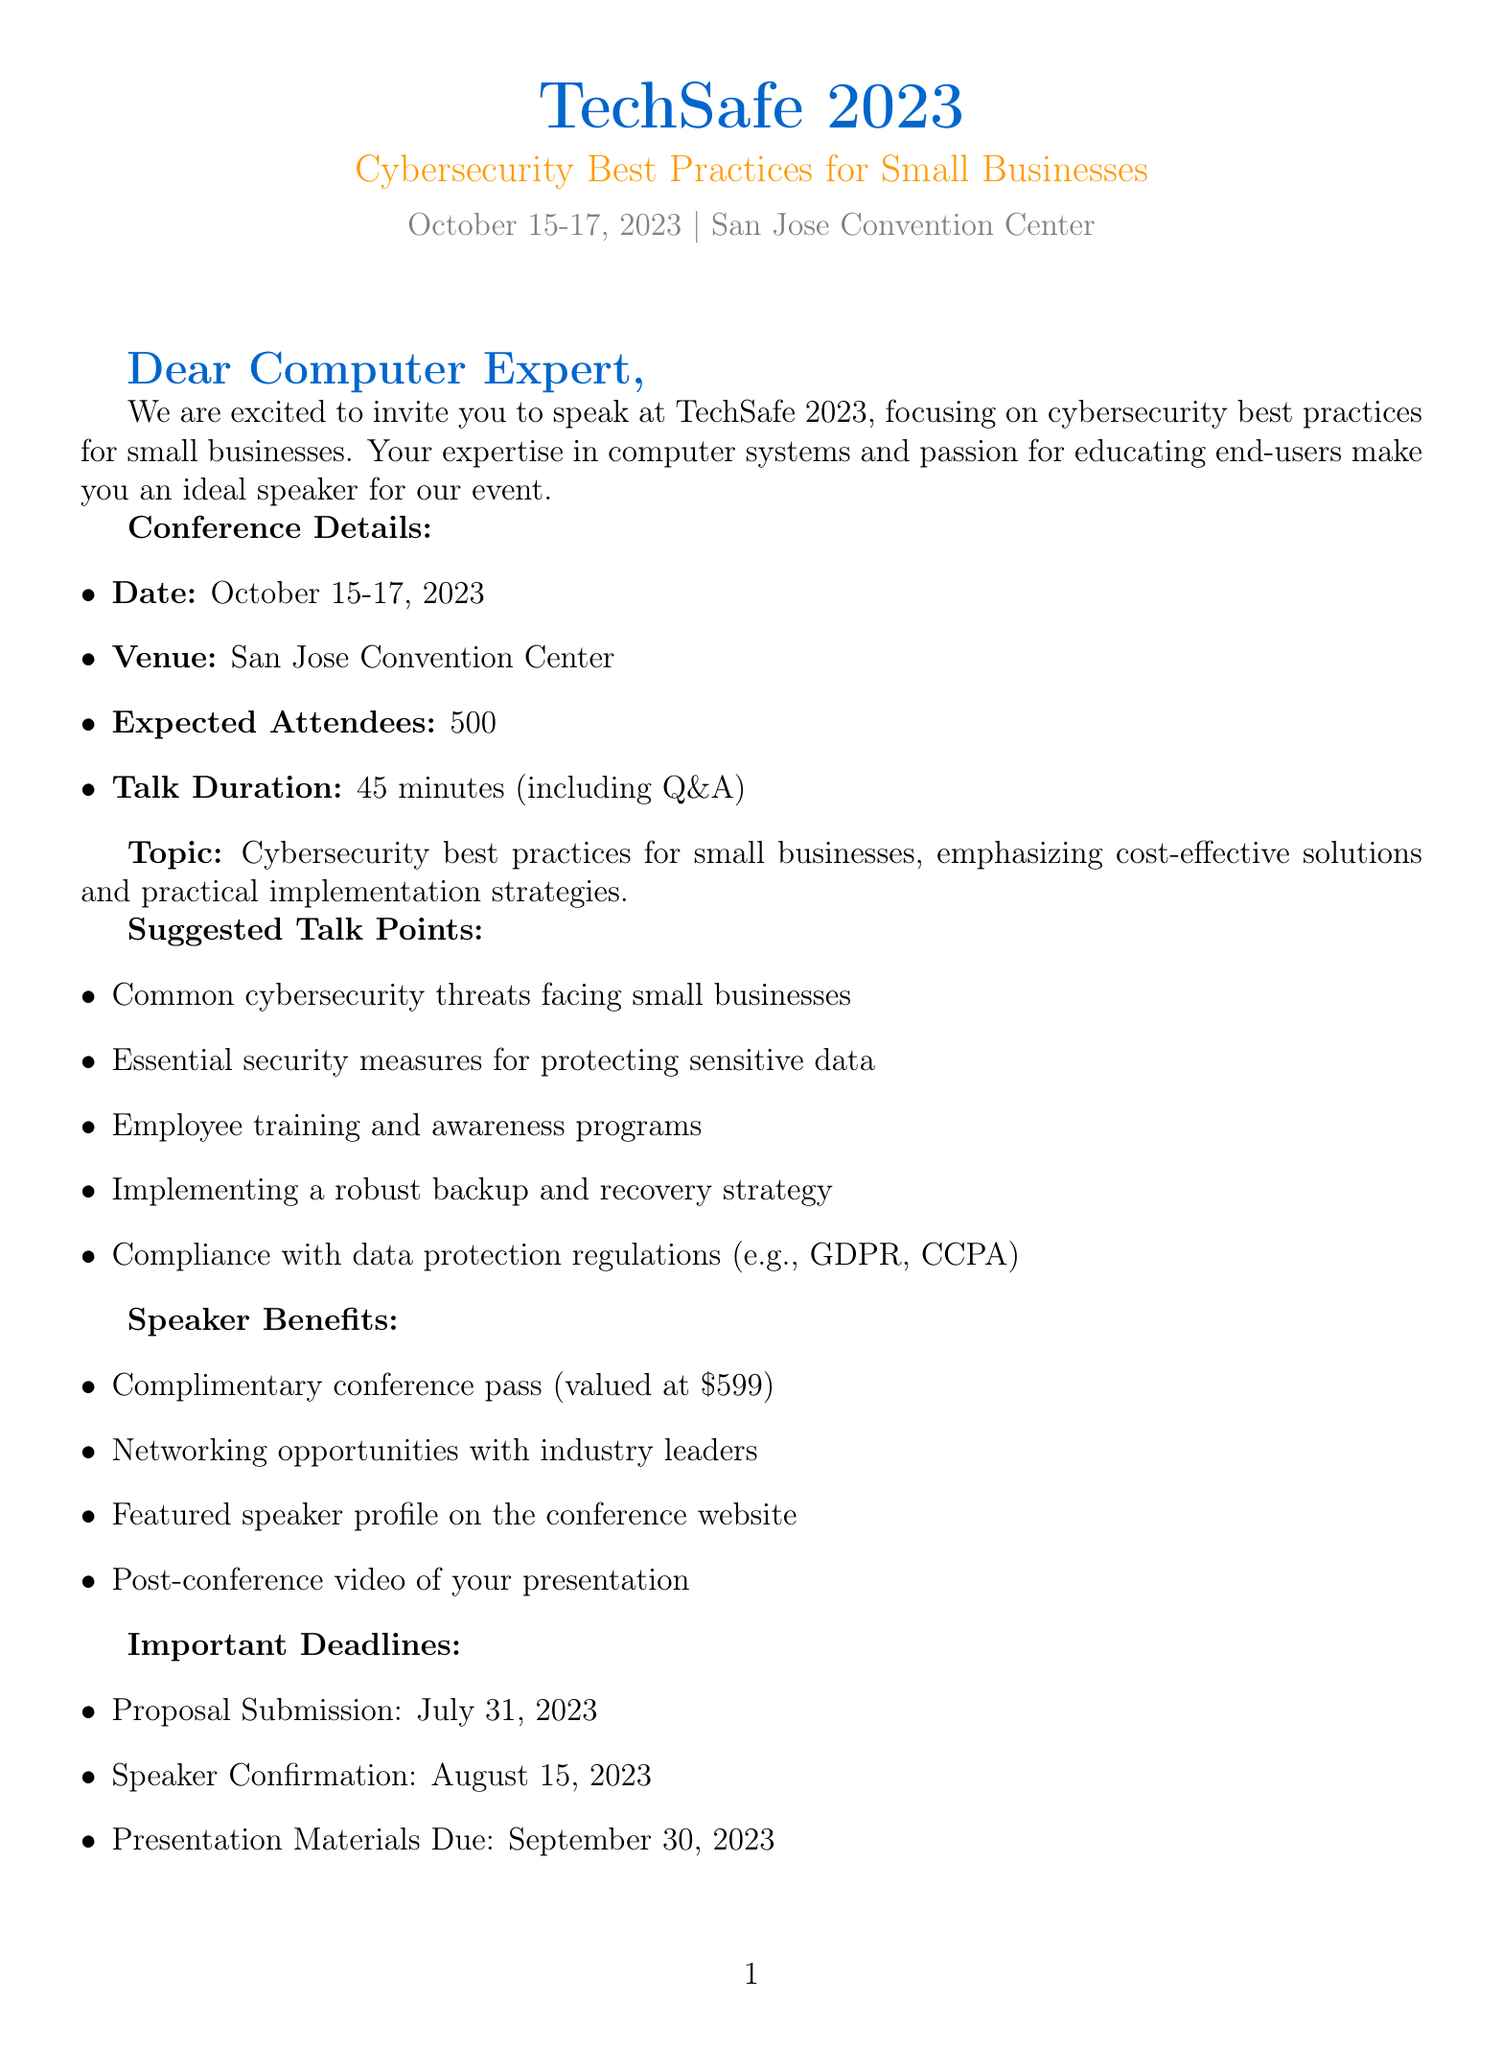What is the name of the conference? The name of the conference is mentioned in the document as TechSafe 2023.
Answer: TechSafe 2023 What are the dates of the conference? The document states the conference will be held from October 15-17, 2023.
Answer: October 15-17, 2023 How long is the talk duration? The talk duration is specified in the document as 45 minutes, including a Q&A session.
Answer: 45 minutes Who is the contact person for the conference? The document identifies Sarah Chen as the speaker coordinator for the event.
Answer: Sarah Chen What is one of the speaker benefits mentioned? The document lists multiple speaker benefits, one being a complimentary conference pass valued at $599.
Answer: Complimentary conference pass (valued at $599) What is one suggested talk point? One of the suggested talk points is about common cybersecurity threats facing small businesses.
Answer: Common cybersecurity threats facing small businesses When is the proposal submission deadline? The deadline for proposal submission is explicitly stated in the document as July 31, 2023.
Answer: July 31, 2023 What is the expected number of attendees? The document mentions an expected attendance of 500 at the conference.
Answer: 500 What is the target audience for the presentation? The document indicates that small business owners are part of the potential audience for the event.
Answer: Small business owners 